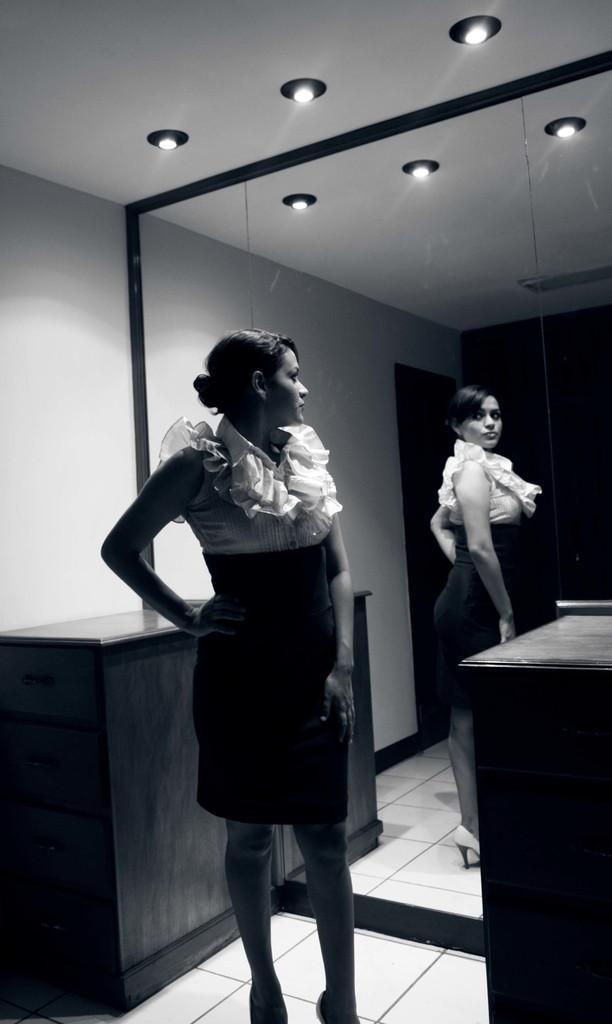Please provide a concise description of this image. In this image I see a woman who is standing in front of a mirror and there is a cupboard behind her and lights on the ceiling. 